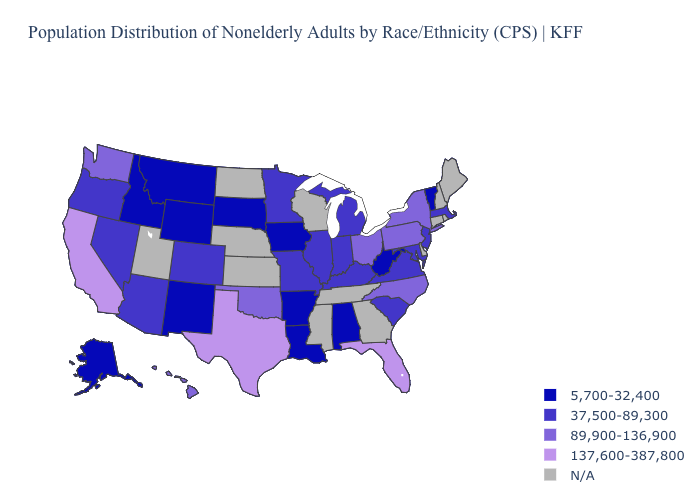Name the states that have a value in the range 89,900-136,900?
Short answer required. Hawaii, New York, North Carolina, Ohio, Oklahoma, Pennsylvania, Washington. What is the value of Hawaii?
Give a very brief answer. 89,900-136,900. What is the value of Nevada?
Write a very short answer. 37,500-89,300. What is the value of Virginia?
Give a very brief answer. 37,500-89,300. What is the value of Nevada?
Answer briefly. 37,500-89,300. Does Florida have the highest value in the USA?
Write a very short answer. Yes. Does the first symbol in the legend represent the smallest category?
Give a very brief answer. Yes. Does Missouri have the lowest value in the USA?
Give a very brief answer. No. What is the highest value in the West ?
Give a very brief answer. 137,600-387,800. What is the lowest value in the Northeast?
Give a very brief answer. 5,700-32,400. Among the states that border Illinois , which have the highest value?
Be succinct. Indiana, Kentucky, Missouri. What is the lowest value in the USA?
Give a very brief answer. 5,700-32,400. Does Texas have the highest value in the USA?
Quick response, please. Yes. Which states have the lowest value in the West?
Be succinct. Alaska, Idaho, Montana, New Mexico, Wyoming. 